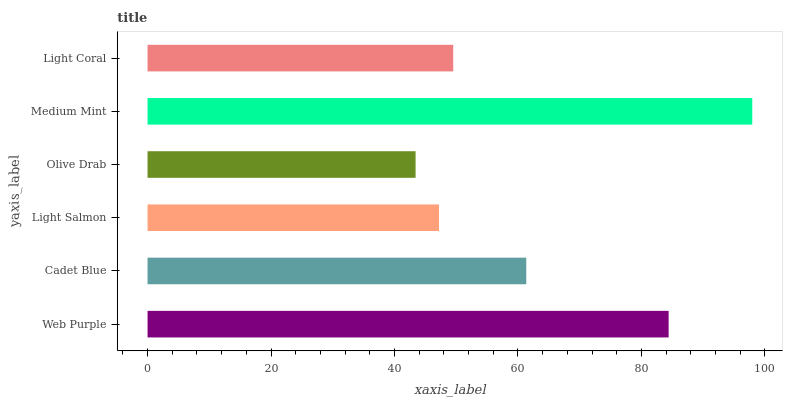Is Olive Drab the minimum?
Answer yes or no. Yes. Is Medium Mint the maximum?
Answer yes or no. Yes. Is Cadet Blue the minimum?
Answer yes or no. No. Is Cadet Blue the maximum?
Answer yes or no. No. Is Web Purple greater than Cadet Blue?
Answer yes or no. Yes. Is Cadet Blue less than Web Purple?
Answer yes or no. Yes. Is Cadet Blue greater than Web Purple?
Answer yes or no. No. Is Web Purple less than Cadet Blue?
Answer yes or no. No. Is Cadet Blue the high median?
Answer yes or no. Yes. Is Light Coral the low median?
Answer yes or no. Yes. Is Light Coral the high median?
Answer yes or no. No. Is Cadet Blue the low median?
Answer yes or no. No. 